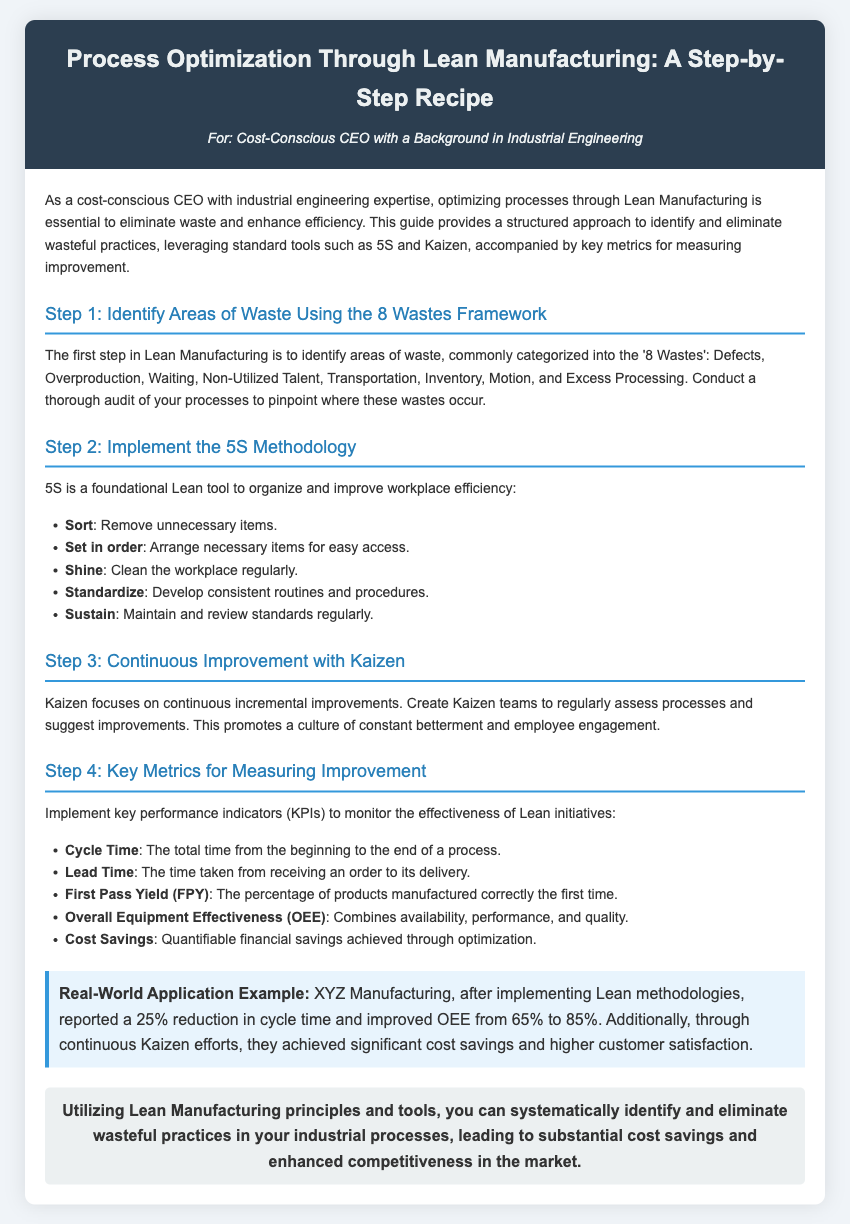What is the main focus of Lean Manufacturing? The document states that the main focus of Lean Manufacturing is to identify and eliminate wasteful practices, enhance efficiency, and optimize processes.
Answer: Optimize processes What are the '8 Wastes' in Lean Manufacturing? The 8 Wastes referred to in the document include Defects, Overproduction, Waiting, Non-Utilized Talent, Transportation, Inventory, Motion, and Excess Processing.
Answer: 8 Wastes What does 5S stand for? The 5S methodology stands for Sort, Set in order, Shine, Standardize, and Sustain.
Answer: Sort, Set in order, Shine, Standardize, Sustain What is one key metric for measuring improvement? One of the key metrics mentioned in the document for measuring improvement is Overall Equipment Effectiveness (OEE).
Answer: Overall Equipment Effectiveness (OEE) What percentage did XYZ Manufacturing improve OEE from and to? The document states that XYZ Manufacturing improved OEE from 65% to 85%.
Answer: 65% to 85% What does Kaizen promote? According to the document, Kaizen promotes a culture of constant betterment and employee engagement through continuous incremental improvements.
Answer: Constant betterment and employee engagement How many steps are outlined in the recipe for process optimization? The document outlines four steps in the recipe for process optimization.
Answer: Four steps What type of teams should be created according to Step 3? The document indicates that Kaizen teams should be created for assessing processes and suggesting improvements.
Answer: Kaizen teams 